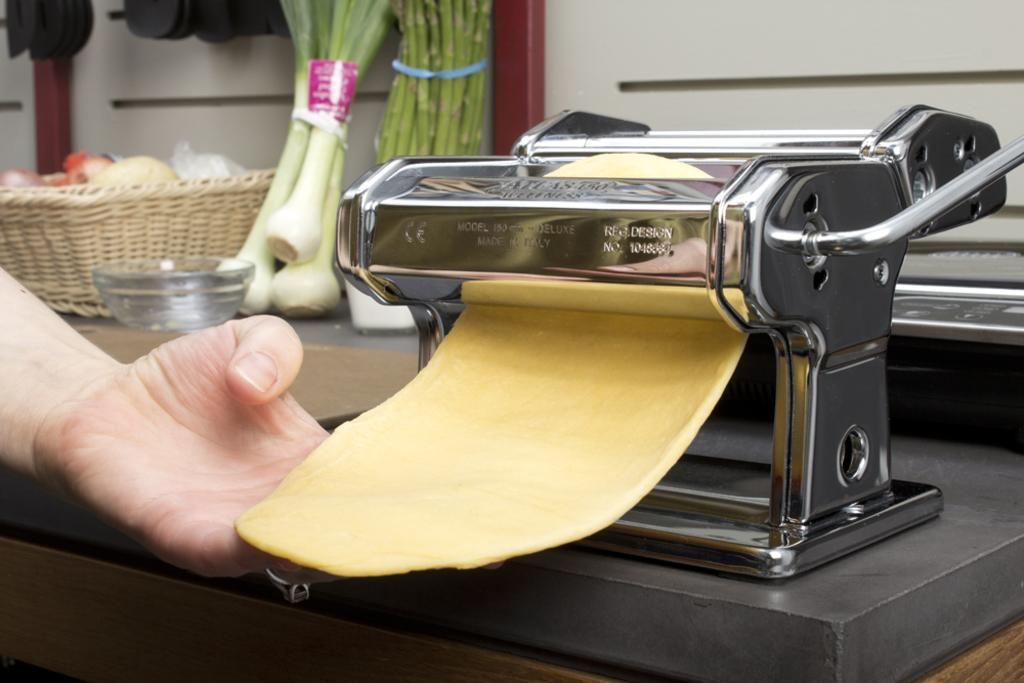<image>
Describe the image concisely. A stainless steel pasta press with REG DESIGN NO 1046664 embossed on the macine 